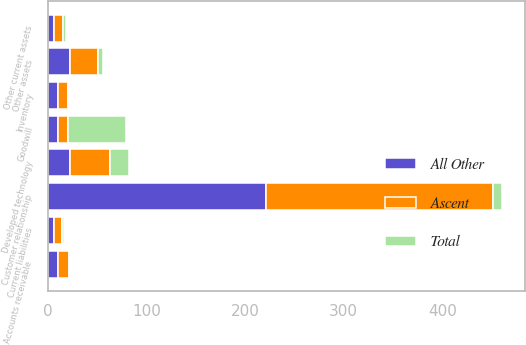Convert chart to OTSL. <chart><loc_0><loc_0><loc_500><loc_500><stacked_bar_chart><ecel><fcel>Accounts receivable<fcel>Inventory<fcel>Other current assets<fcel>Customer relationship<fcel>Developed technology<fcel>Goodwill<fcel>Other assets<fcel>Current liabilities<nl><fcel>All Other<fcel>10.6<fcel>10.3<fcel>6.3<fcel>221.1<fcel>22.5<fcel>10.4<fcel>22.7<fcel>6.3<nl><fcel>Total<fcel>0.1<fcel>0.2<fcel>2.9<fcel>9.1<fcel>18.5<fcel>58.4<fcel>5.2<fcel>2<nl><fcel>Ascent<fcel>10.7<fcel>10.5<fcel>9.2<fcel>230.2<fcel>41<fcel>10.4<fcel>27.9<fcel>8.3<nl></chart> 